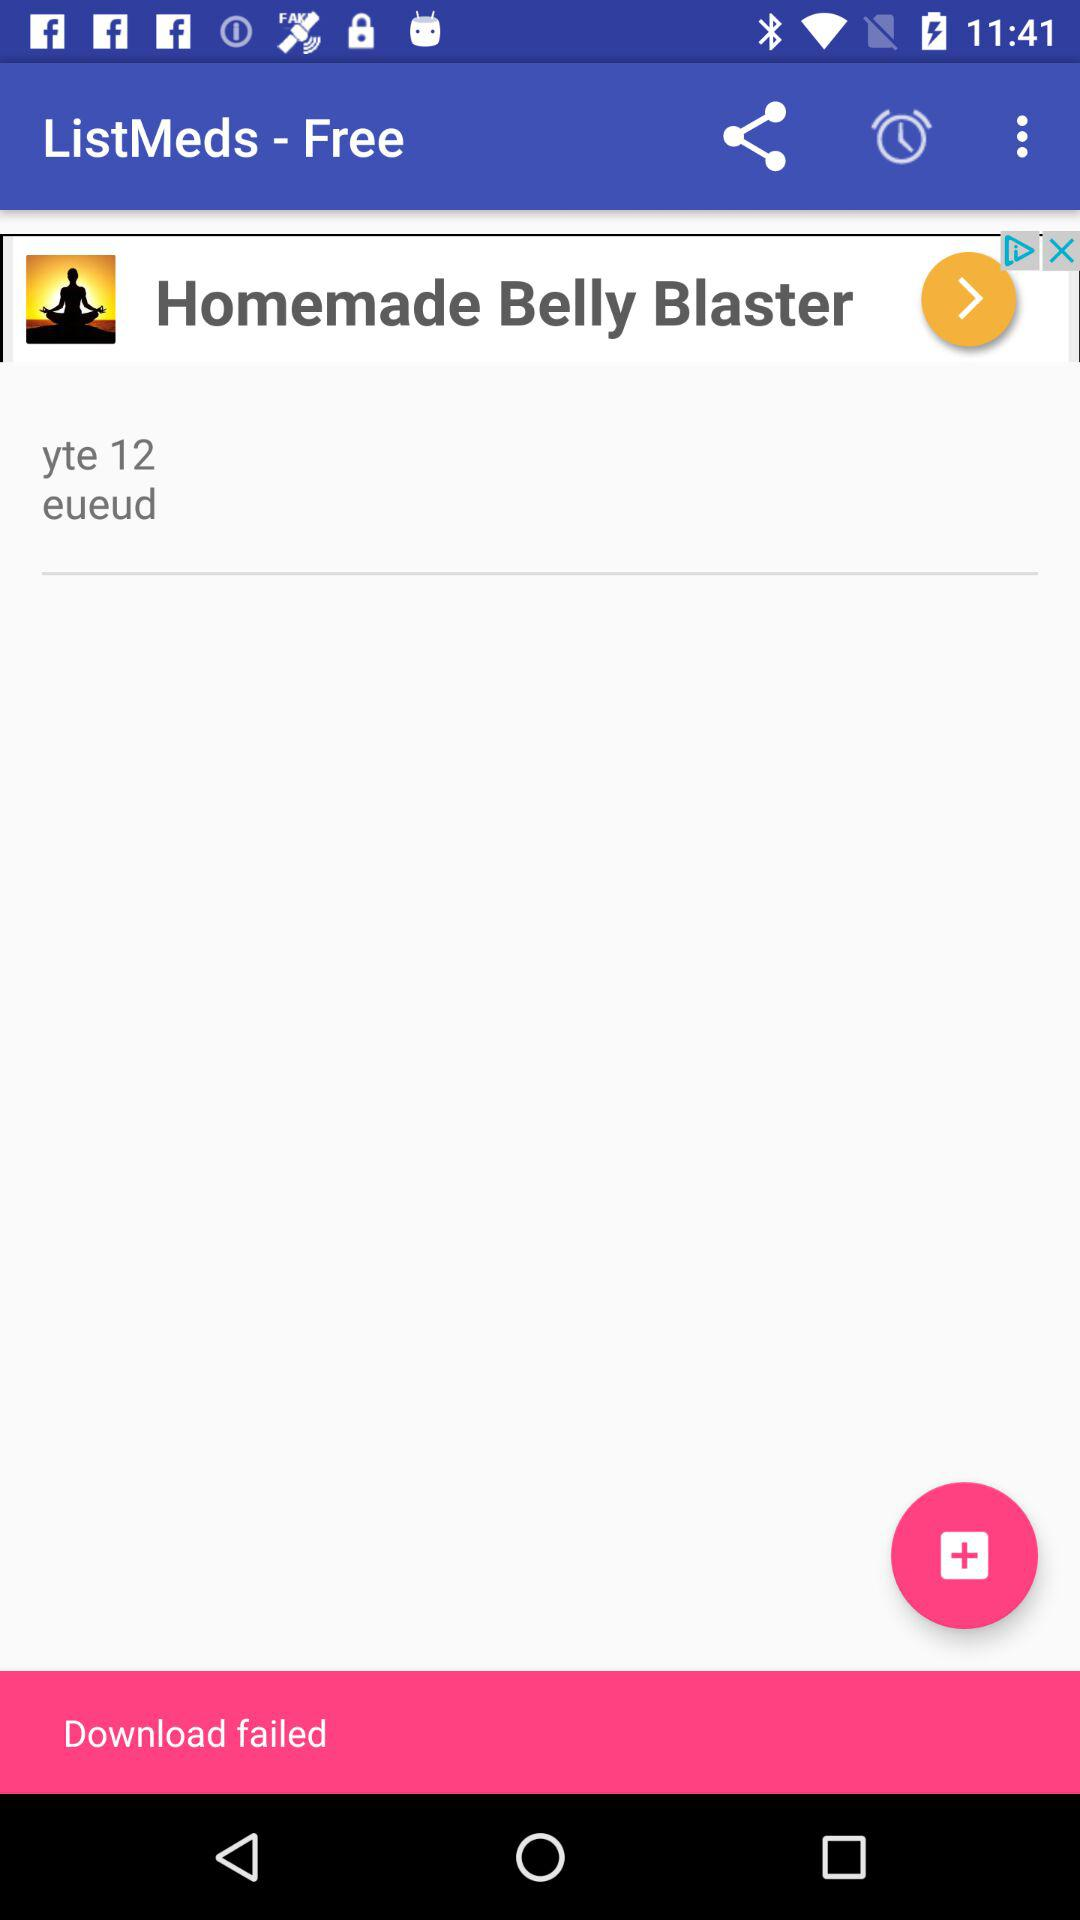What is the name of the application? The name of the application is "ListMeds - Free". 